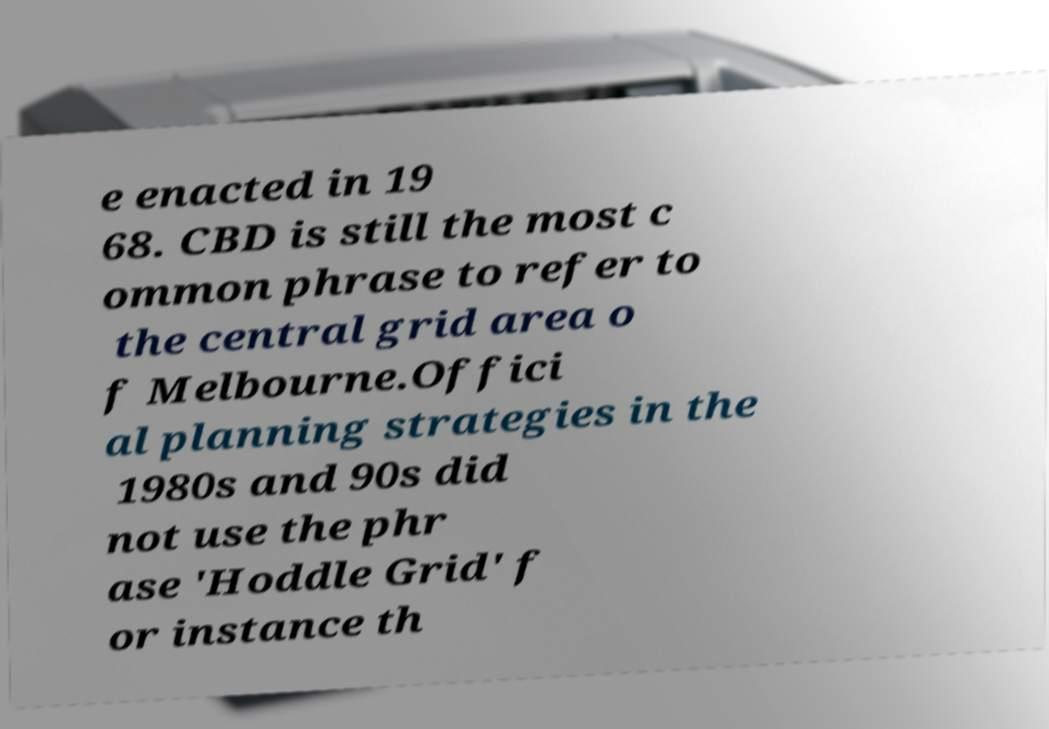Could you extract and type out the text from this image? e enacted in 19 68. CBD is still the most c ommon phrase to refer to the central grid area o f Melbourne.Offici al planning strategies in the 1980s and 90s did not use the phr ase 'Hoddle Grid' f or instance th 